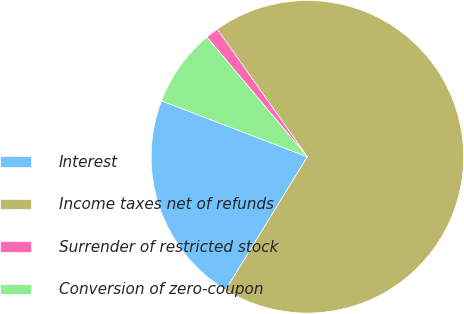<chart> <loc_0><loc_0><loc_500><loc_500><pie_chart><fcel>Interest<fcel>Income taxes net of refunds<fcel>Surrender of restricted stock<fcel>Conversion of zero-coupon<nl><fcel>22.07%<fcel>68.55%<fcel>1.33%<fcel>8.05%<nl></chart> 